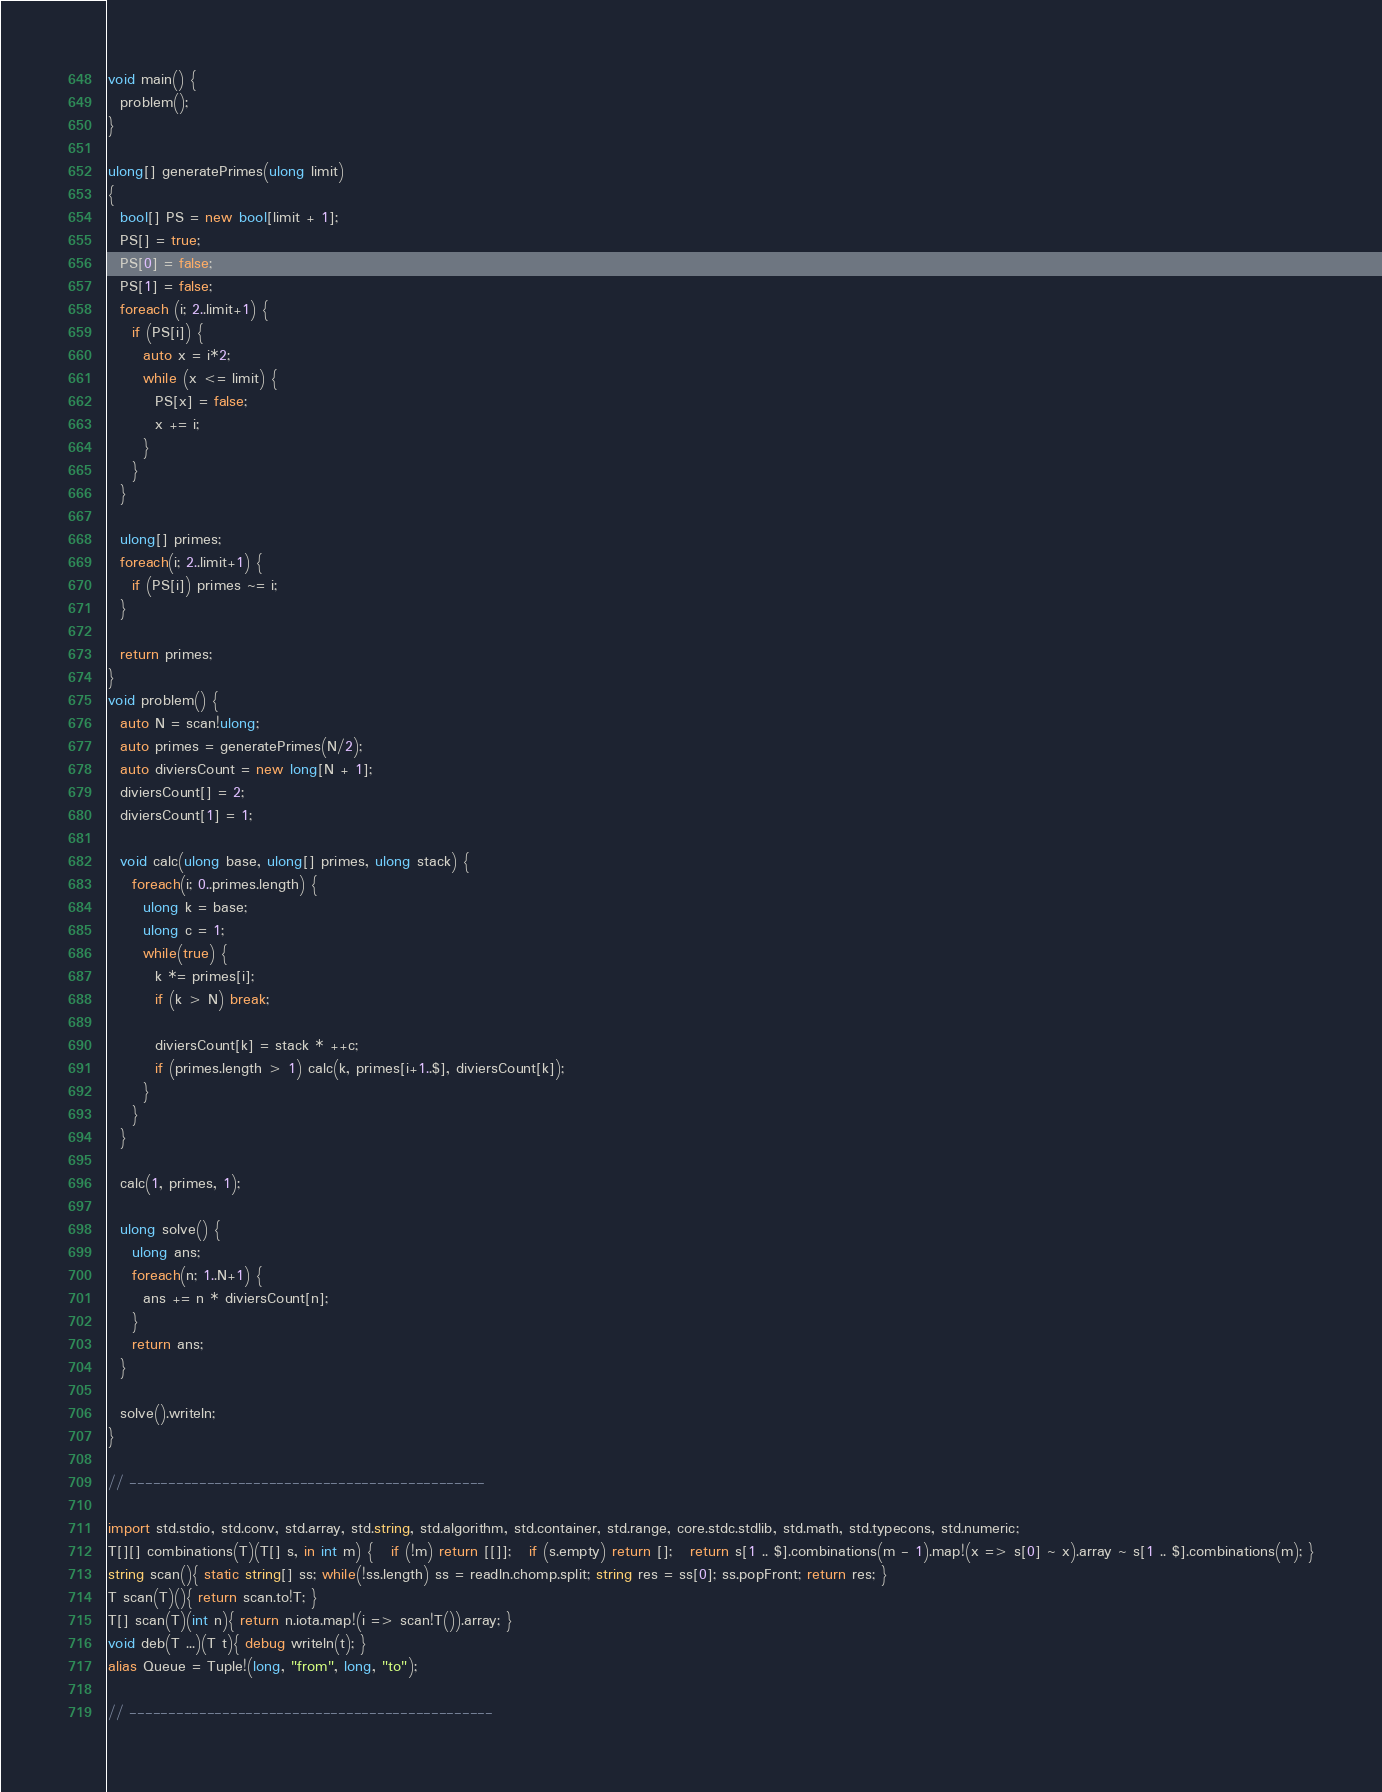Convert code to text. <code><loc_0><loc_0><loc_500><loc_500><_D_>void main() {
  problem();
}

ulong[] generatePrimes(ulong limit)
{
  bool[] PS = new bool[limit + 1];
  PS[] = true;
  PS[0] = false;
  PS[1] = false;
  foreach (i; 2..limit+1) {
    if (PS[i]) {
      auto x = i*2;
      while (x <= limit) {
        PS[x] = false;
        x += i;
      }
    }
  }

  ulong[] primes;
  foreach(i; 2..limit+1) {
    if (PS[i]) primes ~= i;
  }

  return primes;
}
void problem() {
  auto N = scan!ulong;
  auto primes = generatePrimes(N/2);
  auto diviersCount = new long[N + 1];
  diviersCount[] = 2;
  diviersCount[1] = 1;

  void calc(ulong base, ulong[] primes, ulong stack) {
    foreach(i; 0..primes.length) {
      ulong k = base;
      ulong c = 1;
      while(true) {
        k *= primes[i];
        if (k > N) break;

        diviersCount[k] = stack * ++c;
        if (primes.length > 1) calc(k, primes[i+1..$], diviersCount[k]);
      }
    }
  }

  calc(1, primes, 1);

  ulong solve() {
    ulong ans;
    foreach(n; 1..N+1) {
      ans += n * diviersCount[n];
    }
    return ans;
  }

  solve().writeln;
}

// ----------------------------------------------

import std.stdio, std.conv, std.array, std.string, std.algorithm, std.container, std.range, core.stdc.stdlib, std.math, std.typecons, std.numeric;
T[][] combinations(T)(T[] s, in int m) {   if (!m) return [[]];   if (s.empty) return [];   return s[1 .. $].combinations(m - 1).map!(x => s[0] ~ x).array ~ s[1 .. $].combinations(m); }
string scan(){ static string[] ss; while(!ss.length) ss = readln.chomp.split; string res = ss[0]; ss.popFront; return res; }
T scan(T)(){ return scan.to!T; }
T[] scan(T)(int n){ return n.iota.map!(i => scan!T()).array; }
void deb(T ...)(T t){ debug writeln(t); }
alias Queue = Tuple!(long, "from", long, "to");

// -----------------------------------------------
</code> 